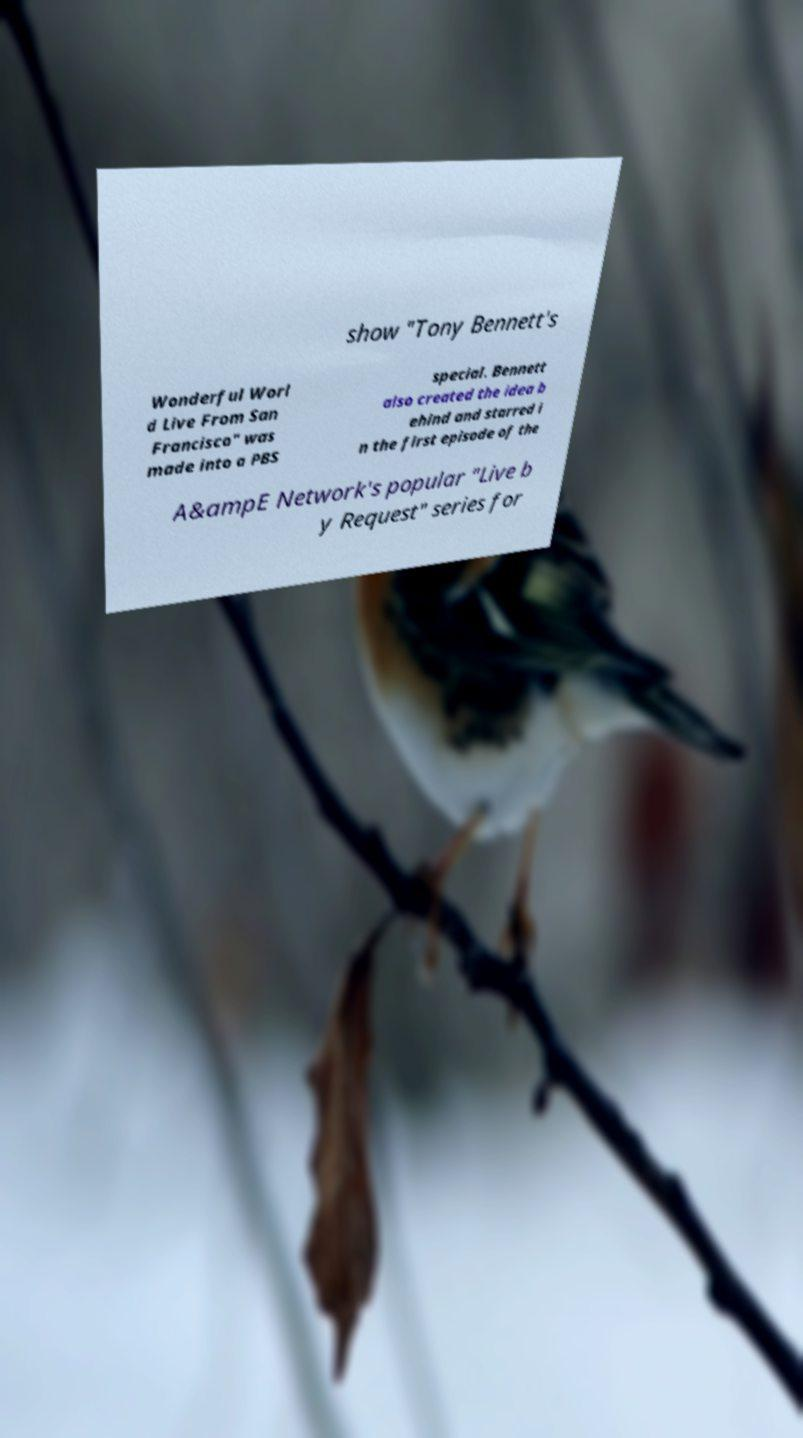There's text embedded in this image that I need extracted. Can you transcribe it verbatim? show "Tony Bennett's Wonderful Worl d Live From San Francisco" was made into a PBS special. Bennett also created the idea b ehind and starred i n the first episode of the A&ampE Network's popular "Live b y Request" series for 